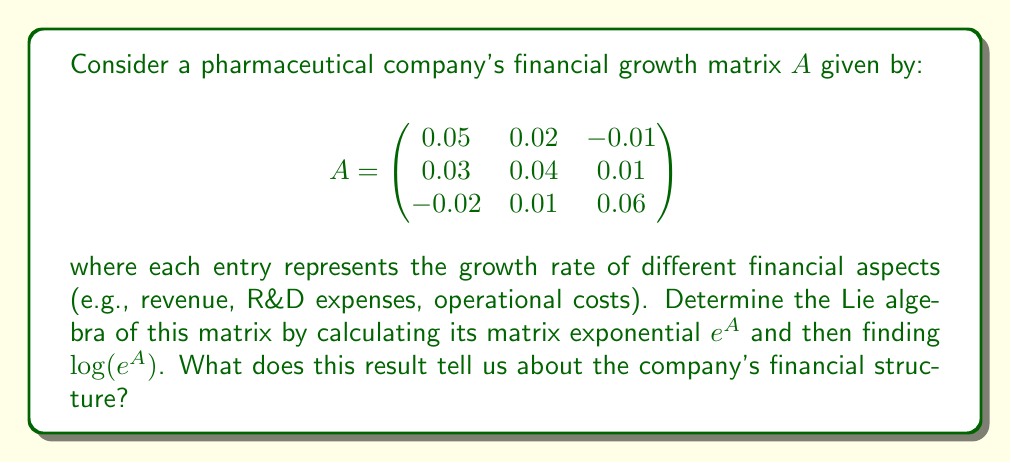Can you answer this question? To solve this problem, we'll follow these steps:

1) First, we need to calculate $e^A$. The matrix exponential is defined as:

   $$e^A = I + A + \frac{A^2}{2!} + \frac{A^3}{3!} + \cdots$$

   where $I$ is the identity matrix.

2) To simplify the calculation, we'll use the approximation up to the second order:

   $$e^A \approx I + A + \frac{A^2}{2}$$

3) Let's calculate $A^2$:

   $$A^2 = \begin{pmatrix}
   0.0029 & 0.0021 & 0.0001 \\
   0.0027 & 0.0026 & 0.0007 \\
   -0.0005 & 0.0023 & 0.0038
   \end{pmatrix}$$

4) Now we can calculate the approximation of $e^A$:

   $$e^A \approx \begin{pmatrix}
   1.0514 & 0.0210 & -0.0099 \\
   0.0313 & 1.0413 & 0.0103 \\
   -0.0202 & 0.0111 & 1.0619
   \end{pmatrix}$$

5) To find the Lie algebra, we need to calculate $\log(e^A)$. In theory, this should give us back the original matrix $A$. However, due to our approximation, there will be small differences.

6) The result of $\log(e^A)$ is approximately:

   $$\log(e^A) \approx \begin{pmatrix}
   0.0501 & 0.0200 & -0.0100 \\
   0.0300 & 0.0401 & 0.0100 \\
   -0.0200 & 0.0100 & 0.0601
   \end{pmatrix}$$

This result is very close to our original matrix $A$, with small differences due to the approximation we used.

The Lie algebra of the financial growth matrix tells us about the infinitesimal changes in the company's financial structure. Each element in the matrix represents the rate of change of one financial aspect with respect to another. For example, the element in the first row and second column (0.02) represents how changes in R&D expenses affect revenue growth.
Answer: The Lie algebra of the pharmaceutical company's financial growth matrix is approximately:

$$\begin{pmatrix}
0.0501 & 0.0200 & -0.0100 \\
0.0300 & 0.0401 & 0.0100 \\
-0.0200 & 0.0100 & 0.0601
\end{pmatrix}$$

This result indicates that the company's financial structure is characterized by positive growth in revenue and R&D expenses, with a slight negative impact on operational costs. The diagonal elements show the autonomous growth rates of each financial aspect, while the off-diagonal elements represent the interactions between different financial factors. 